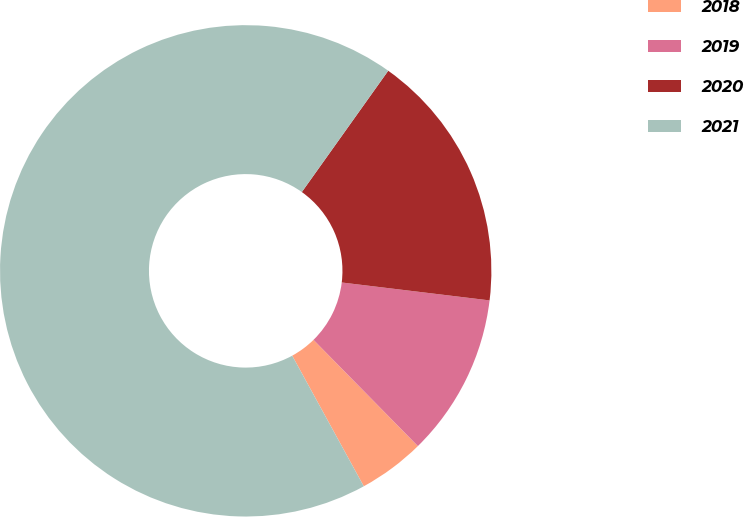Convert chart to OTSL. <chart><loc_0><loc_0><loc_500><loc_500><pie_chart><fcel>2018<fcel>2019<fcel>2020<fcel>2021<nl><fcel>4.38%<fcel>10.72%<fcel>17.07%<fcel>67.83%<nl></chart> 